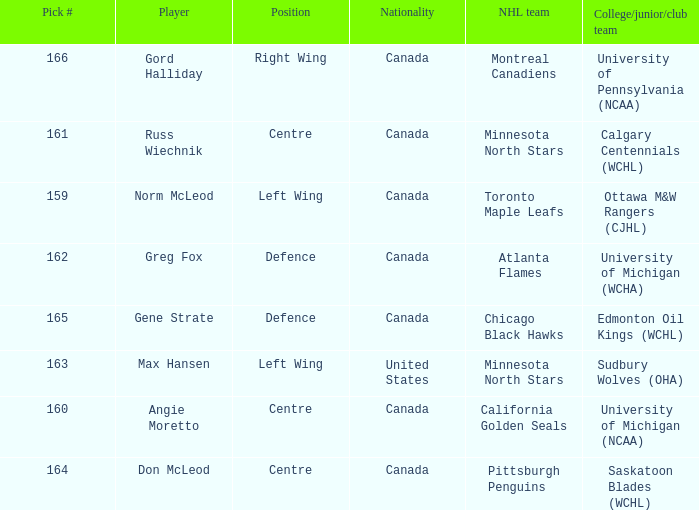Help me parse the entirety of this table. {'header': ['Pick #', 'Player', 'Position', 'Nationality', 'NHL team', 'College/junior/club team'], 'rows': [['166', 'Gord Halliday', 'Right Wing', 'Canada', 'Montreal Canadiens', 'University of Pennsylvania (NCAA)'], ['161', 'Russ Wiechnik', 'Centre', 'Canada', 'Minnesota North Stars', 'Calgary Centennials (WCHL)'], ['159', 'Norm McLeod', 'Left Wing', 'Canada', 'Toronto Maple Leafs', 'Ottawa M&W Rangers (CJHL)'], ['162', 'Greg Fox', 'Defence', 'Canada', 'Atlanta Flames', 'University of Michigan (WCHA)'], ['165', 'Gene Strate', 'Defence', 'Canada', 'Chicago Black Hawks', 'Edmonton Oil Kings (WCHL)'], ['163', 'Max Hansen', 'Left Wing', 'United States', 'Minnesota North Stars', 'Sudbury Wolves (OHA)'], ['160', 'Angie Moretto', 'Centre', 'Canada', 'California Golden Seals', 'University of Michigan (NCAA)'], ['164', 'Don McLeod', 'Centre', 'Canada', 'Pittsburgh Penguins', 'Saskatoon Blades (WCHL)']]} How many players have the pick number 166? 1.0. 